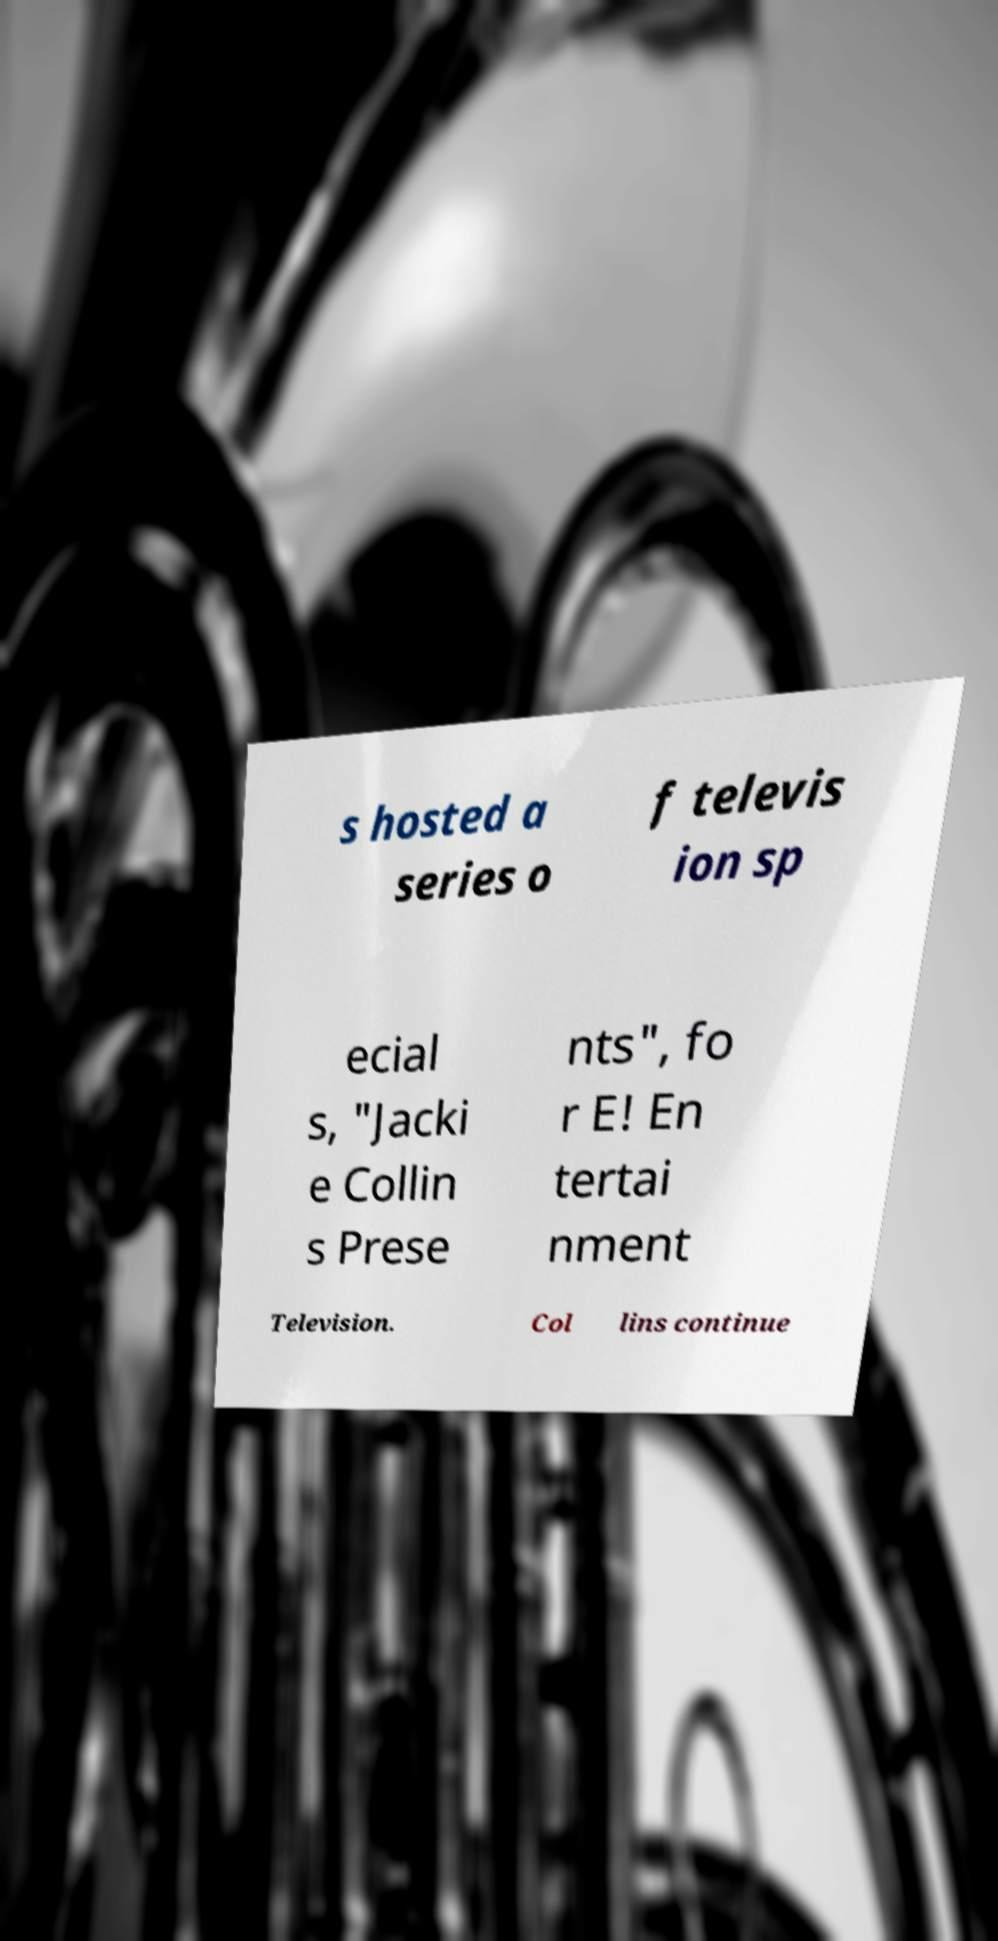There's text embedded in this image that I need extracted. Can you transcribe it verbatim? s hosted a series o f televis ion sp ecial s, "Jacki e Collin s Prese nts", fo r E! En tertai nment Television. Col lins continue 